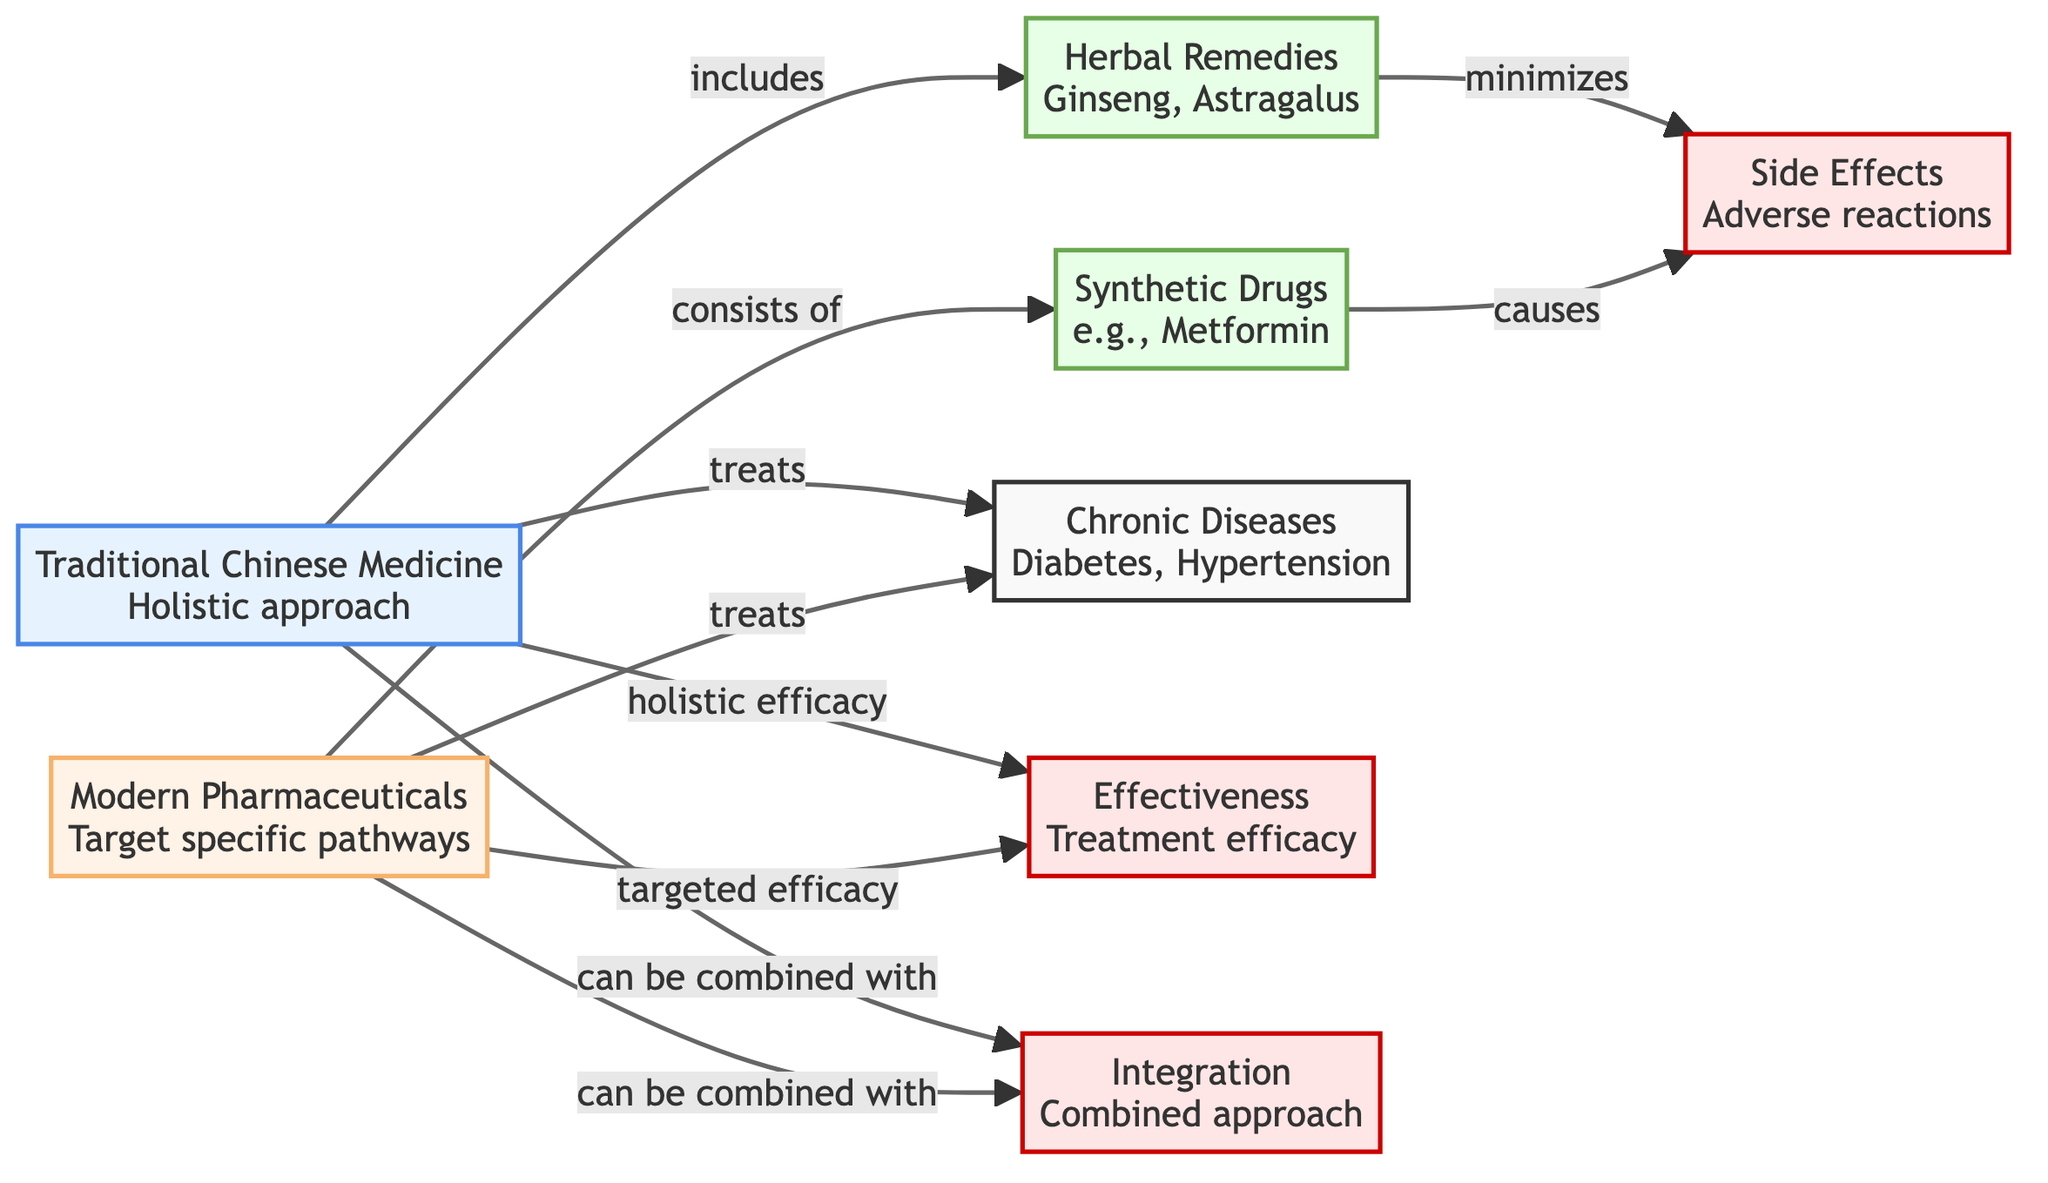What are the two main approaches in the diagram? The diagram clearly shows two distinct approaches: Traditional Chinese Medicine and Modern Pharmaceuticals. These are the main categories represented in the diagram.
Answer: Traditional Chinese Medicine, Modern Pharmaceuticals Which chronic diseases are treated by both Traditional Chinese Medicine and Modern Pharmaceuticals? The diagram identifies Chronic Diseases as the common target for both approaches, specifically mentioning Diabetes and Hypertension, which fall under this category.
Answer: Diabetes, Hypertension What type of remedies does Traditional Chinese Medicine include? The diagram specifies that Traditional Chinese Medicine includes Herbal Remedies, with examples like Ginseng and Astragalus provided to illustrate this category.
Answer: Herbal Remedies What kind of drugs does Modern Pharmaceuticals consist of? According to the diagram, Modern Pharmaceuticals consists of Synthetic Drugs, with Metformin provided as a specific example to represent this type of treatment.
Answer: Synthetic Drugs Which approach minimizes side effects? The diagram indicates that Herbal Remedies, under Traditional Chinese Medicine, are linked to minimizing Side Effects, while Synthetic Drugs are associated with causing Side Effects.
Answer: Herbal Remedies In terms of effectiveness, how do Traditional Chinese Medicine and Modern Pharmaceuticals differ? The diagram specifies that Traditional Chinese Medicine is linked to holistic efficacy while Modern Pharmaceuticals are linked to targeted efficacy, showcasing a difference in their approaches to effectiveness.
Answer: Holistic efficacy, Targeted efficacy Can Traditional Chinese Medicine be combined with other approaches? The diagram indicates that Traditional Chinese Medicine can be combined with additional treatments, signified by the connection to Integration, showing its compatibility with other forms of therapy.
Answer: Yes What is a notable outcome of taking Synthetic Drugs? According to the diagram, a notable outcome associated with taking Synthetic Drugs is the occurrence of Side Effects, indicating potential adverse reactions.
Answer: Side Effects How is effectiveness portrayed for both Traditional Chinese Medicine and Modern Pharmaceuticals? The diagram shows that both approaches aim for Effectiveness, but while Traditional Chinese Medicine is illustrated as having holistic efficacy, Modern Pharmaceuticals are depicted with targeted efficacy, reflecting a broader versus a more focused approach.
Answer: Holistic efficacy, Targeted efficacy 